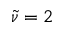Convert formula to latex. <formula><loc_0><loc_0><loc_500><loc_500>\widetilde { \nu } = 2</formula> 